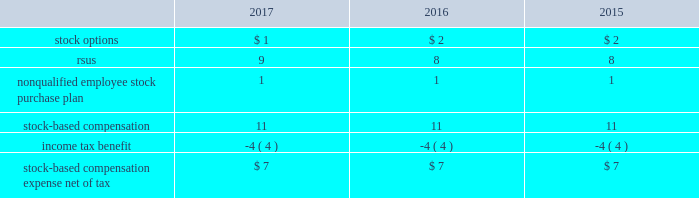On may 12 , 2017 , the company 2019s stockholders approved the american water works company , inc .
2017 omnibus equity compensation plan ( the 201c2017 omnibus plan 201d ) .
A total of 7.2 million shares of common stock may be issued under the 2017 omnibus plan .
As of december 31 , 2017 , 7.2 million shares were available for grant under the 2017 omnibus plan .
The 2017 omnibus plan provides that grants of awards may be in any of the following forms : incentive stock options , nonqualified stock options , stock appreciation rights , stock units , stock awards , other stock-based awards and dividend equivalents , which may be granted only on stock units or other stock-based awards .
Following the approval of the 2017 omnibus plan , no additional awards are to be granted under the 2007 plan .
However , shares will still be issued under the 2007 plan pursuant to the terms of awards previously issued under that plan prior to may 12 , 2017 .
The cost of services received from employees in exchange for the issuance of stock options and restricted stock awards is measured based on the grant date fair value of the awards issued .
The value of stock options and rsus awards at the date of the grant is amortized through expense over the three-year service period .
All awards granted in 2017 , 2016 and 2015 are classified as equity .
The company recognizes compensation expense for stock awards over the vesting period of the award .
The company stratified its grant populations and used historic employee turnover rates to estimate employee forfeitures .
The estimated rate is compared to the actual forfeitures at the end of the reporting period and adjusted as necessary .
The table presents stock-based compensation expense recorded in operation and maintenance expense in the accompanying consolidated statements of operations for the years ended december 31: .
There were no significant stock-based compensation costs capitalized during the years ended december 31 , 2017 , 2016 and 2015 .
The company receives a tax deduction based on the intrinsic value of the award at the exercise date for stock options and the distribution date for rsus .
For each award , throughout the requisite service period , the company recognizes the tax benefits , which have been included in deferred income tax assets , related to compensation costs .
The tax deductions in excess of the benefits recorded throughout the requisite service period are recorded to the consolidated statements of operations and are presented in the financing section of the consolidated statements of cash flows .
Stock options there were no grants of stock options to employees in 2017 .
In 2016 and 2015 , the company granted non-qualified stock options to certain employees under the 2007 plan .
The stock options vest ratably over the three-year service period beginning on january 1 of the year of the grant and have no performance vesting conditions .
Expense is recognized using the straight-line method and is amortized over the requisite service period. .
At what tax rate was stock-based compensation being taxed at during the years 2015 , 2016 and 2017? 
Computations: (-4 / 11)
Answer: -0.36364. 